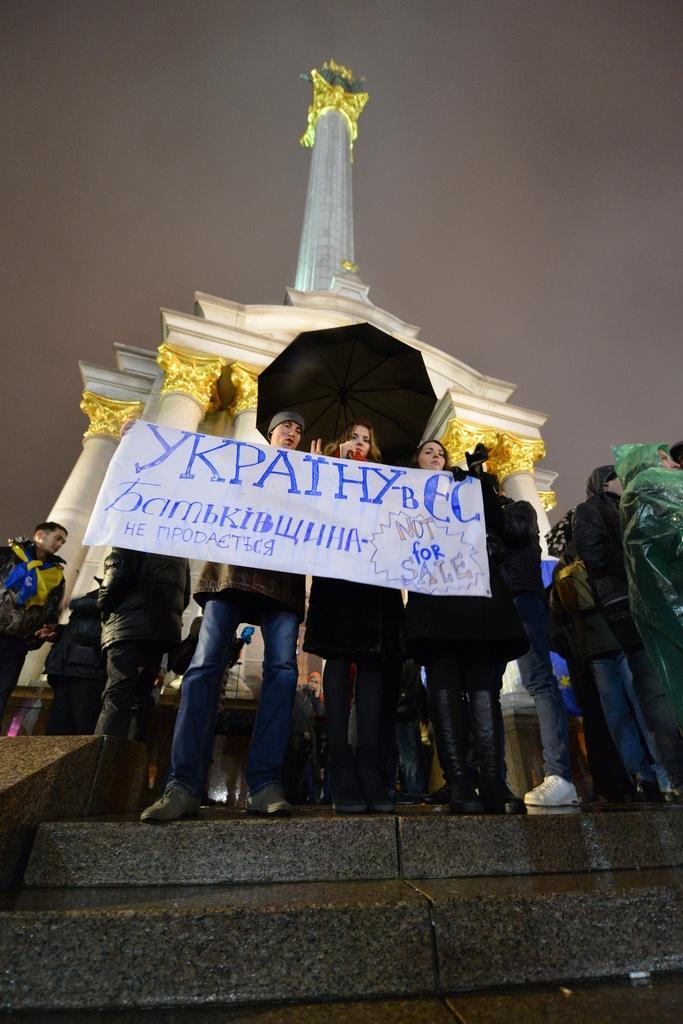Please provide a concise description of this image. In the image in the center we can see few people were standing and holding banner. In the background we can see the sky,clouds,pillars,tower,staircase and few people were standing and holding some objects. 